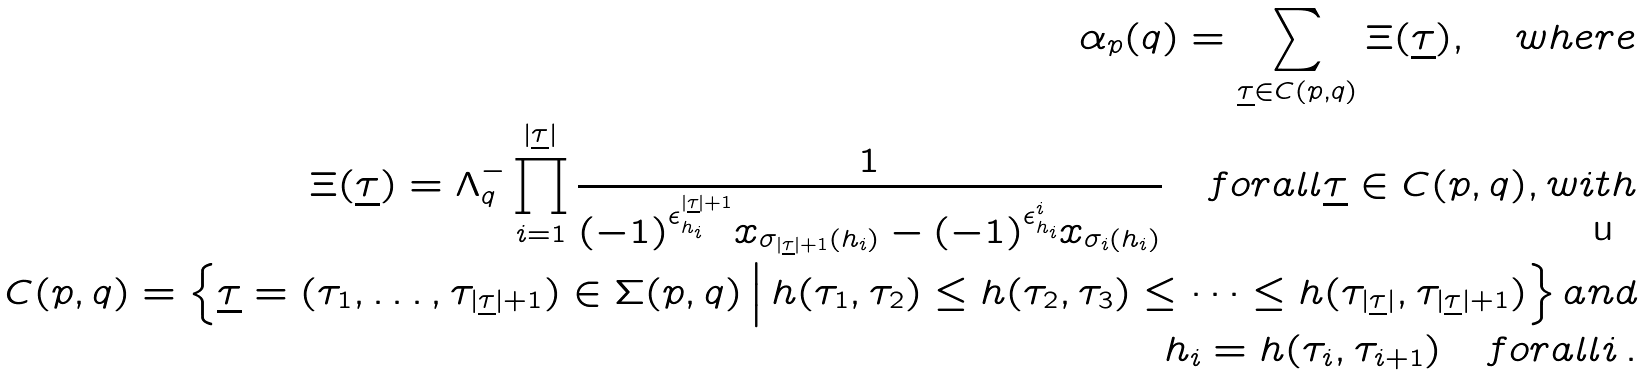<formula> <loc_0><loc_0><loc_500><loc_500>\alpha _ { p } ( q ) = \sum _ { \underline { \tau } \in C ( p , q ) } \Xi ( \underline { \tau } ) , \quad w h e r e \\ \Xi ( \underline { \tau } ) = \Lambda _ { q } ^ { - } \prod _ { i = 1 } ^ { | \underline { \tau } | } \frac { 1 } { ( - 1 ) ^ { \epsilon _ { h _ { i } } ^ { | \underline { \tau } | + 1 } } x _ { \sigma _ { | \underline { \tau } | + 1 } ( h _ { i } ) } - ( - 1 ) ^ { \epsilon _ { h _ { i } } ^ { i } } x _ { \sigma _ { i } ( h _ { i } ) } } \quad f o r a l l \underline { \tau } \in C ( p , q ) , w i t h \\ C ( p , q ) = \Big \{ \underline { \tau } = ( \tau _ { 1 } , \dots , \tau _ { | \underline { \tau } | + 1 } ) \in \Sigma ( p , q ) \, \Big | \, h ( \tau _ { 1 } , \tau _ { 2 } ) \leq h ( \tau _ { 2 } , \tau _ { 3 } ) \leq \dots \leq h ( \tau _ { | \underline { \tau } | } , \tau _ { | \underline { \tau } | + 1 } ) \Big \} \, a n d \\ h _ { i } = h ( \tau _ { i } , \tau _ { i + 1 } ) \quad f o r a l l i \, .</formula> 